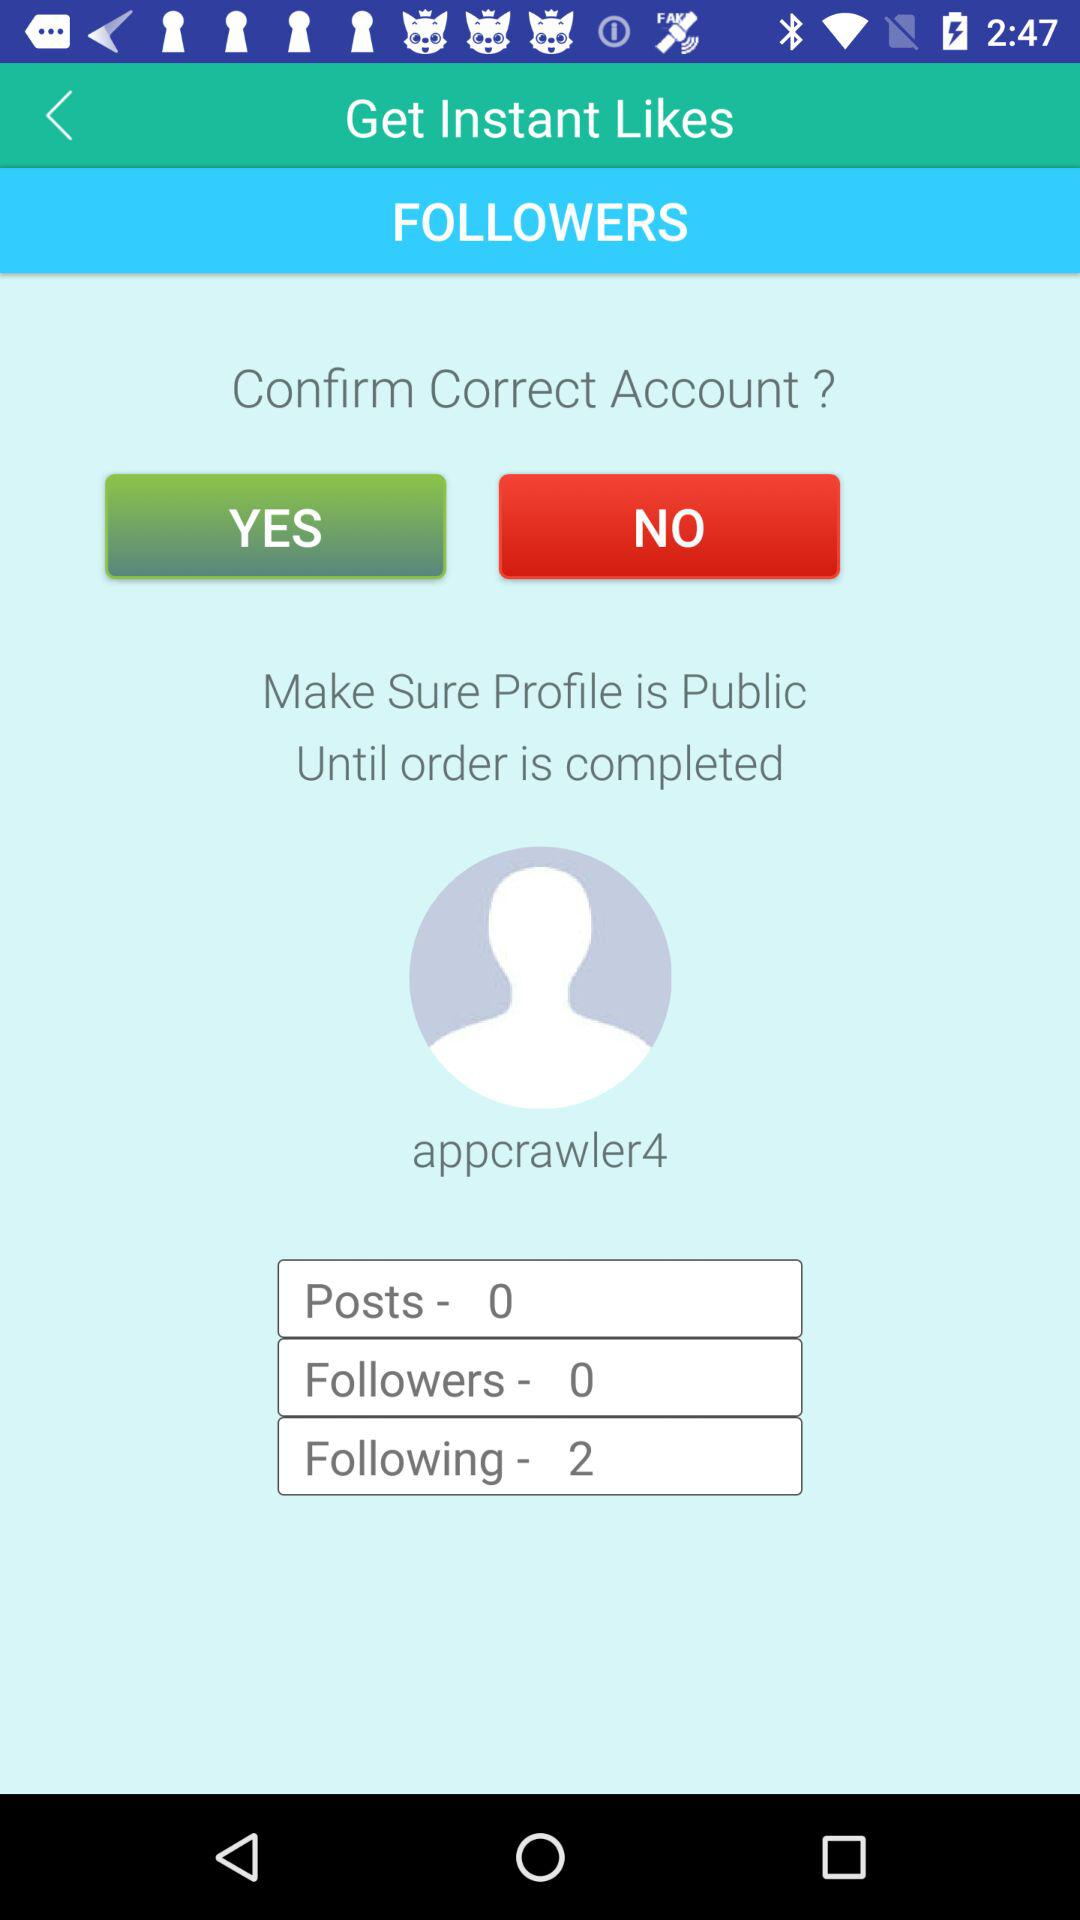How many followers are there? There are 0 followers. 